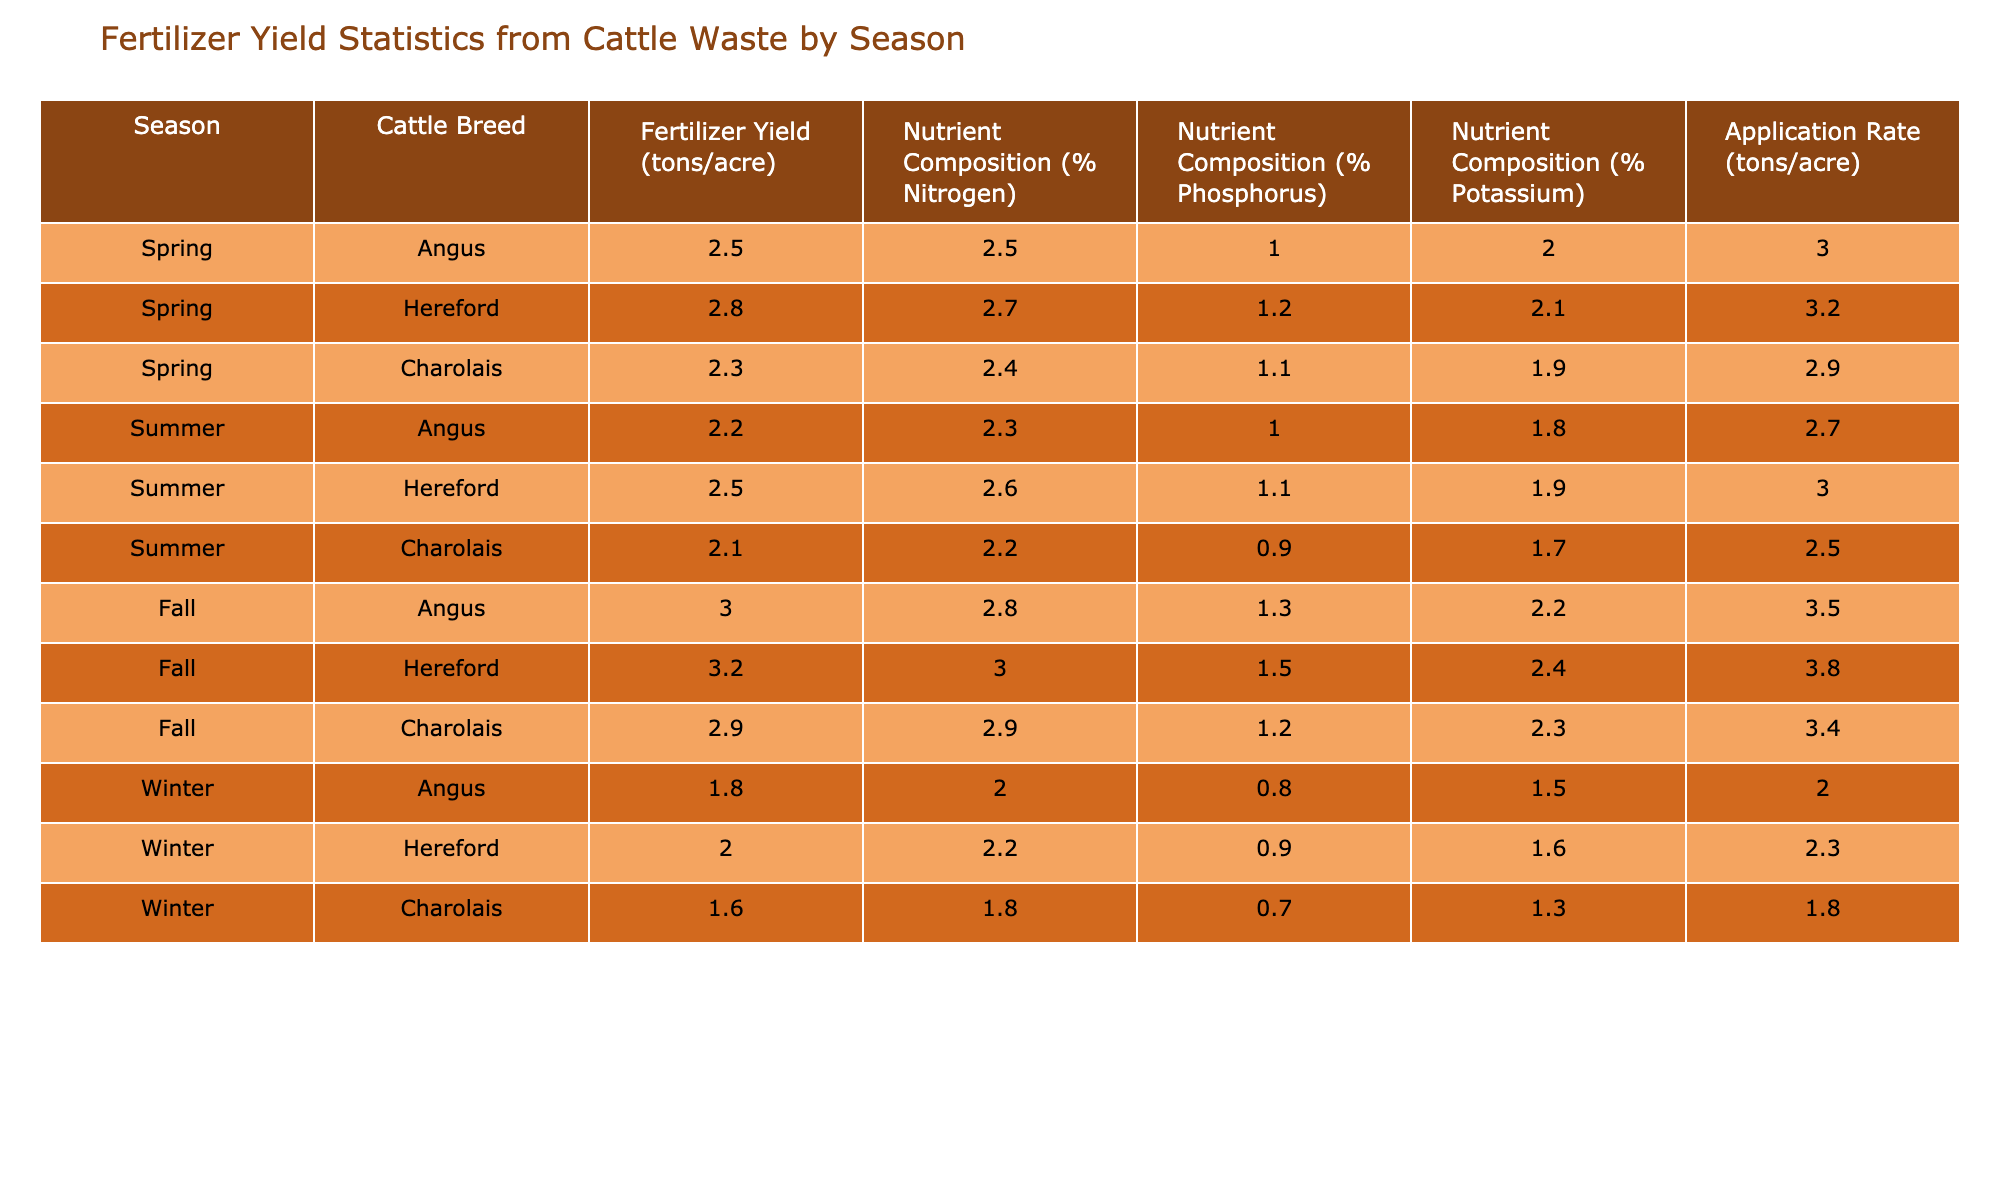What is the highest fertilizer yield recorded in the table? Looking through the table, the highest fertilizer yield is found in the Fall season with the Hereford breed, which has a yield of 3.2 tons/acre.
Answer: 3.2 tons/acre Which cattle breed has the lowest nutrient composition of potassium in Spring? In the Spring season, examining the potassium nutrient composition, the Charolais breed has the lowest percentage at 1.9%.
Answer: 1.9% What is the average fertilizer yield across all cattle breeds in Winter? The fertilizer yields for Winter are 1.8, 2.0, and 1.6 tons/acre for Angus, Hereford, and Charolais respectively. Summing these yields gives us 1.8 + 2.0 + 1.6 = 5.4 tons, and dividing by 3 breeds yields an average of 5.4 / 3 = 1.8 tons/acre.
Answer: 1.8 tons/acre Which season has the highest overall average application rate of fertilizer? The application rates are 3.0, 3.2, 3.2 for Spring; 2.7, 3.0, 2.5 for Summer; 3.5, 3.8, 3.4 for Fall; and 2.0, 2.3, 1.8 for Winter. Adding these rates for each season, we find that Fall yields the highest average when calculated. The Fall average is (3.5 + 3.8 + 3.4) / 3 = 3.57 tons/acre, compared to other seasons.
Answer: Fall Is there any breed that consistently produces the highest fertilizer yield across all seasons? By reviewing the yield figures by breed across all seasons, no single breed shows the highest yield in every season; thus, the answer is false.
Answer: No What is the difference in nutrient composition of nitrogen between Angus and Hereford breeds in the Fall? The nitrogen composition for Angus in the Fall is 2.8%, while for Hereford it is 3.0%. The difference can be calculated as 3.0% - 2.8% = 0.2%.
Answer: 0.2% What is the most consistent cattle breed in terms of fertilizer yield across the seasons? By analyzing the data, Hereford shows the least variation in yield across all four seasons with yields close to each other, while other breeds, like Charolais and Angus, show more fluctuation.
Answer: Hereford Which nutrient composition shows the largest increase in Fall compared to Summer for any breed? Looking at the data, we compare the increases across nutrient compositions. The nitrogen composition for Hereford goes from 2.6% in Summer to 3.0% in Fall, an increase of 0.4%. This is the largest increase observed comparing all breeds.
Answer: 0.4% 